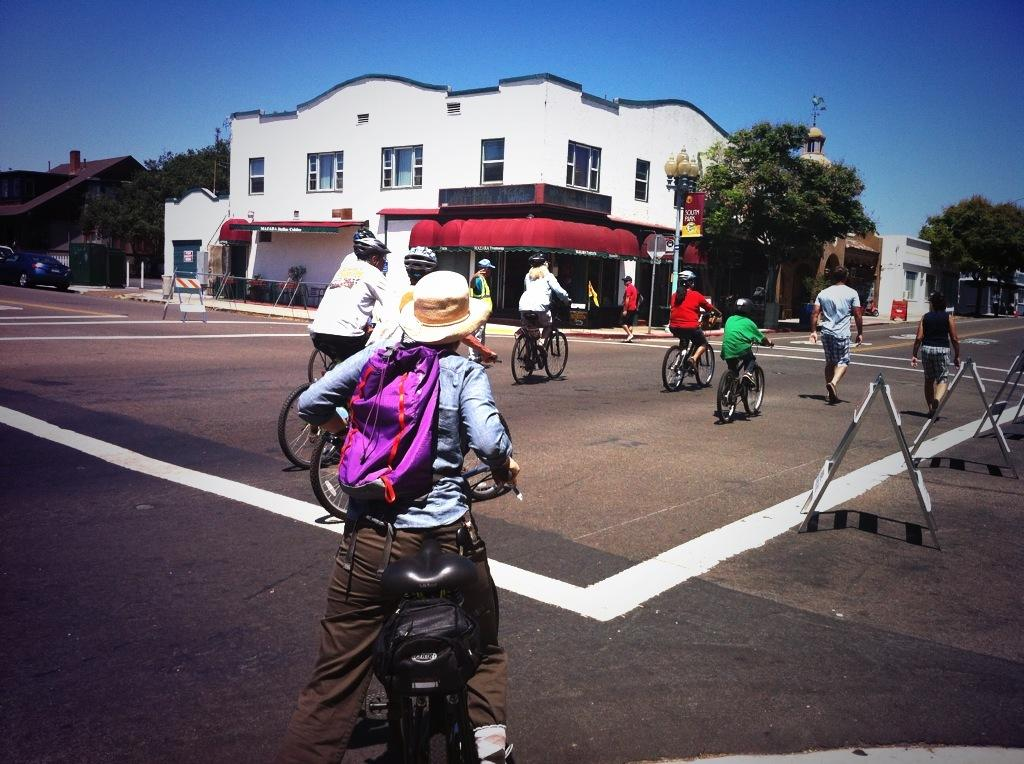How many people are in the image? There is a group of people in the image. What are the people doing in the image? The people are riding a bicycle in the image. Where is the bicycle located? The bicycle is on the road in the image. What can be seen in the backdrop of the image? There are trees, buildings, and vehicles in the backdrop of the image. What is the condition of the sky in the image? The sky is clear in the image. How many wax figures can be seen in the image? There are no wax figures present in the image; it features a group of people riding a bicycle on the road. Is there a bomb visible in the image? No, there is no bomb present in the image. 